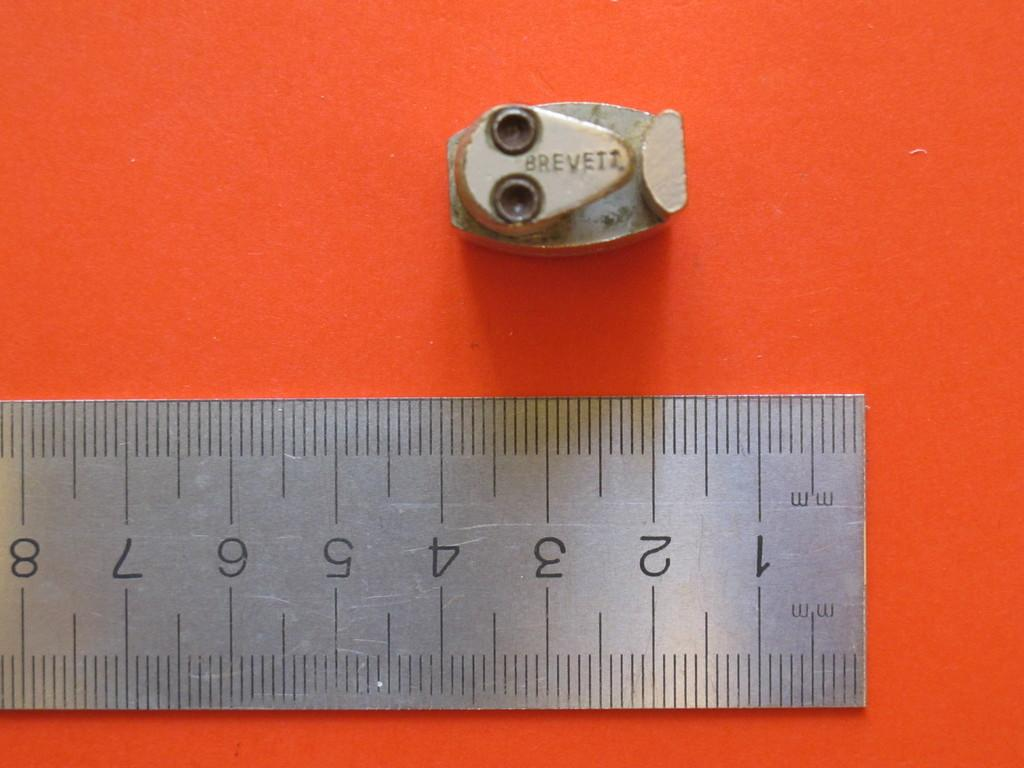<image>
Create a compact narrative representing the image presented. A metal ruler below a metal piece with Brevett written on it. 